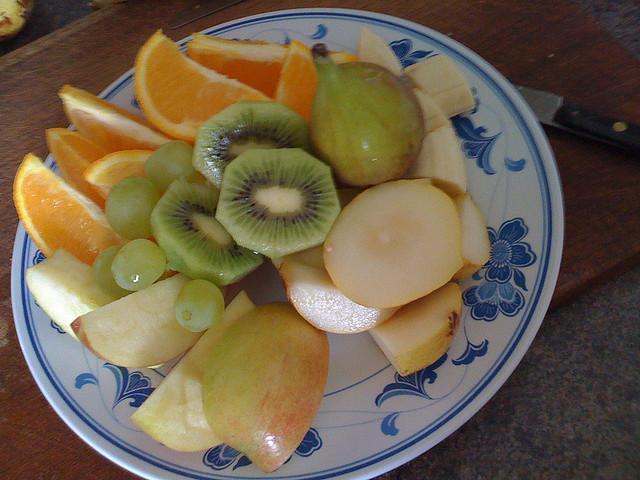How many banana slices are there?
Give a very brief answer. 4. How many slices is the orange cut into?
Give a very brief answer. 8. How many oranges are there?
Give a very brief answer. 6. How many apples can you see?
Give a very brief answer. 3. How many bananas can you see?
Give a very brief answer. 2. How many dining tables are visible?
Give a very brief answer. 2. How many people are looking at the camera?
Give a very brief answer. 0. 